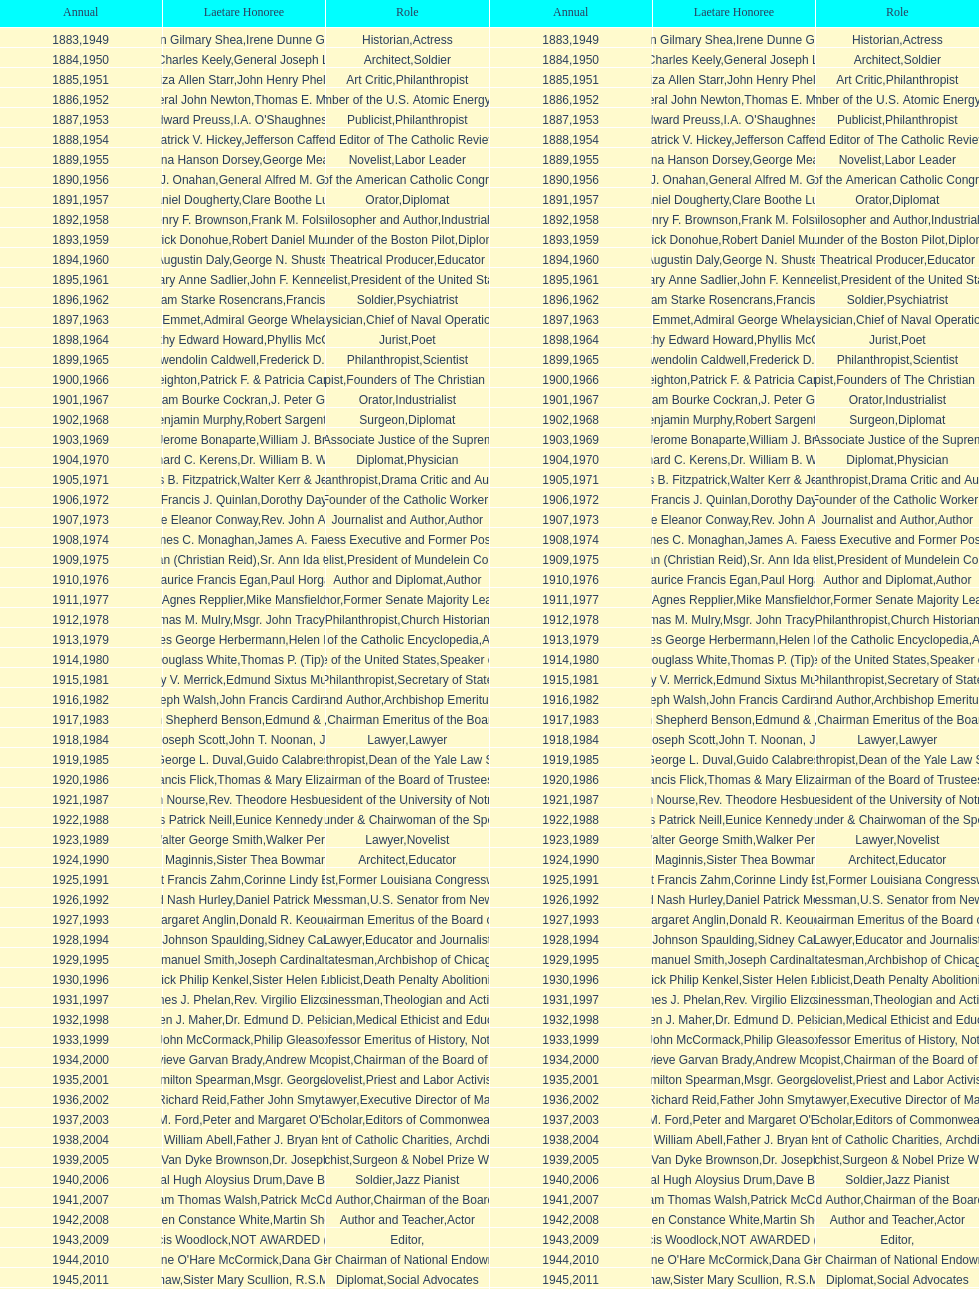How many lawyers have won the award between 1883 and 2014? 5. 